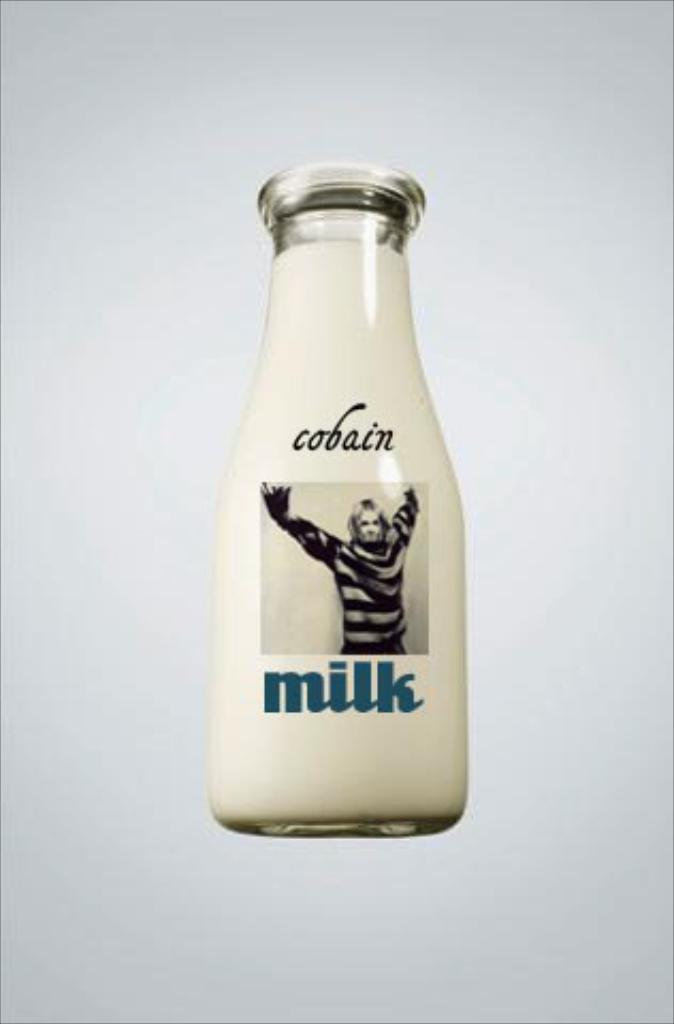In one or two sentences, can you explain what this image depicts? In this image we can see a bottle. On the bottle we can see some text and an image of a person. The background of the image is white. 